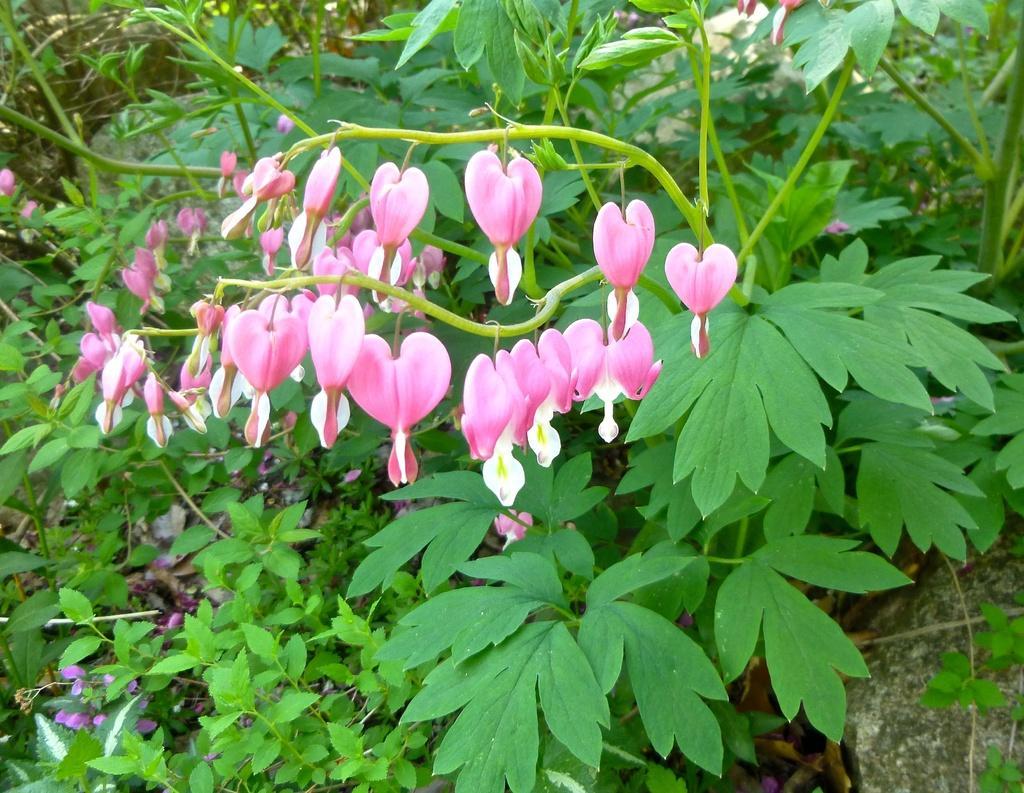What type of living organisms can be seen in the image? There are flowers and plants visible in the image. What non-living object can be seen in the image? There is a rock in the image. What type of tools does the carpenter use in the image? There is no carpenter present in the image, so it is not possible to determine what tools they might use. 